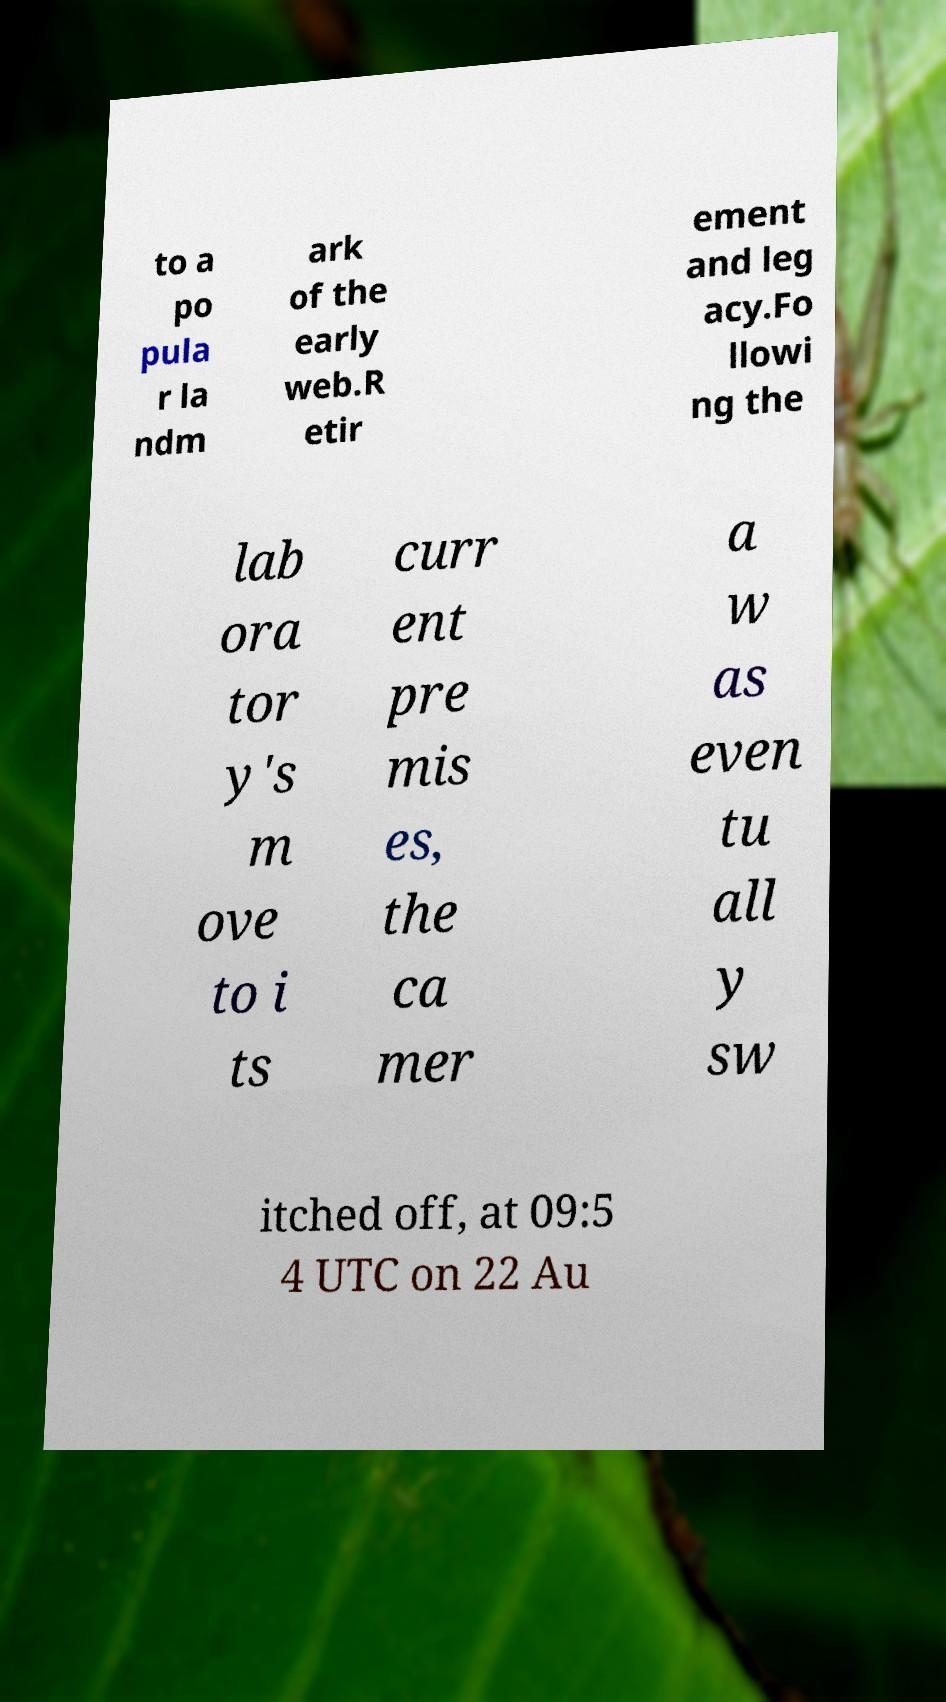For documentation purposes, I need the text within this image transcribed. Could you provide that? to a po pula r la ndm ark of the early web.R etir ement and leg acy.Fo llowi ng the lab ora tor y's m ove to i ts curr ent pre mis es, the ca mer a w as even tu all y sw itched off, at 09:5 4 UTC on 22 Au 